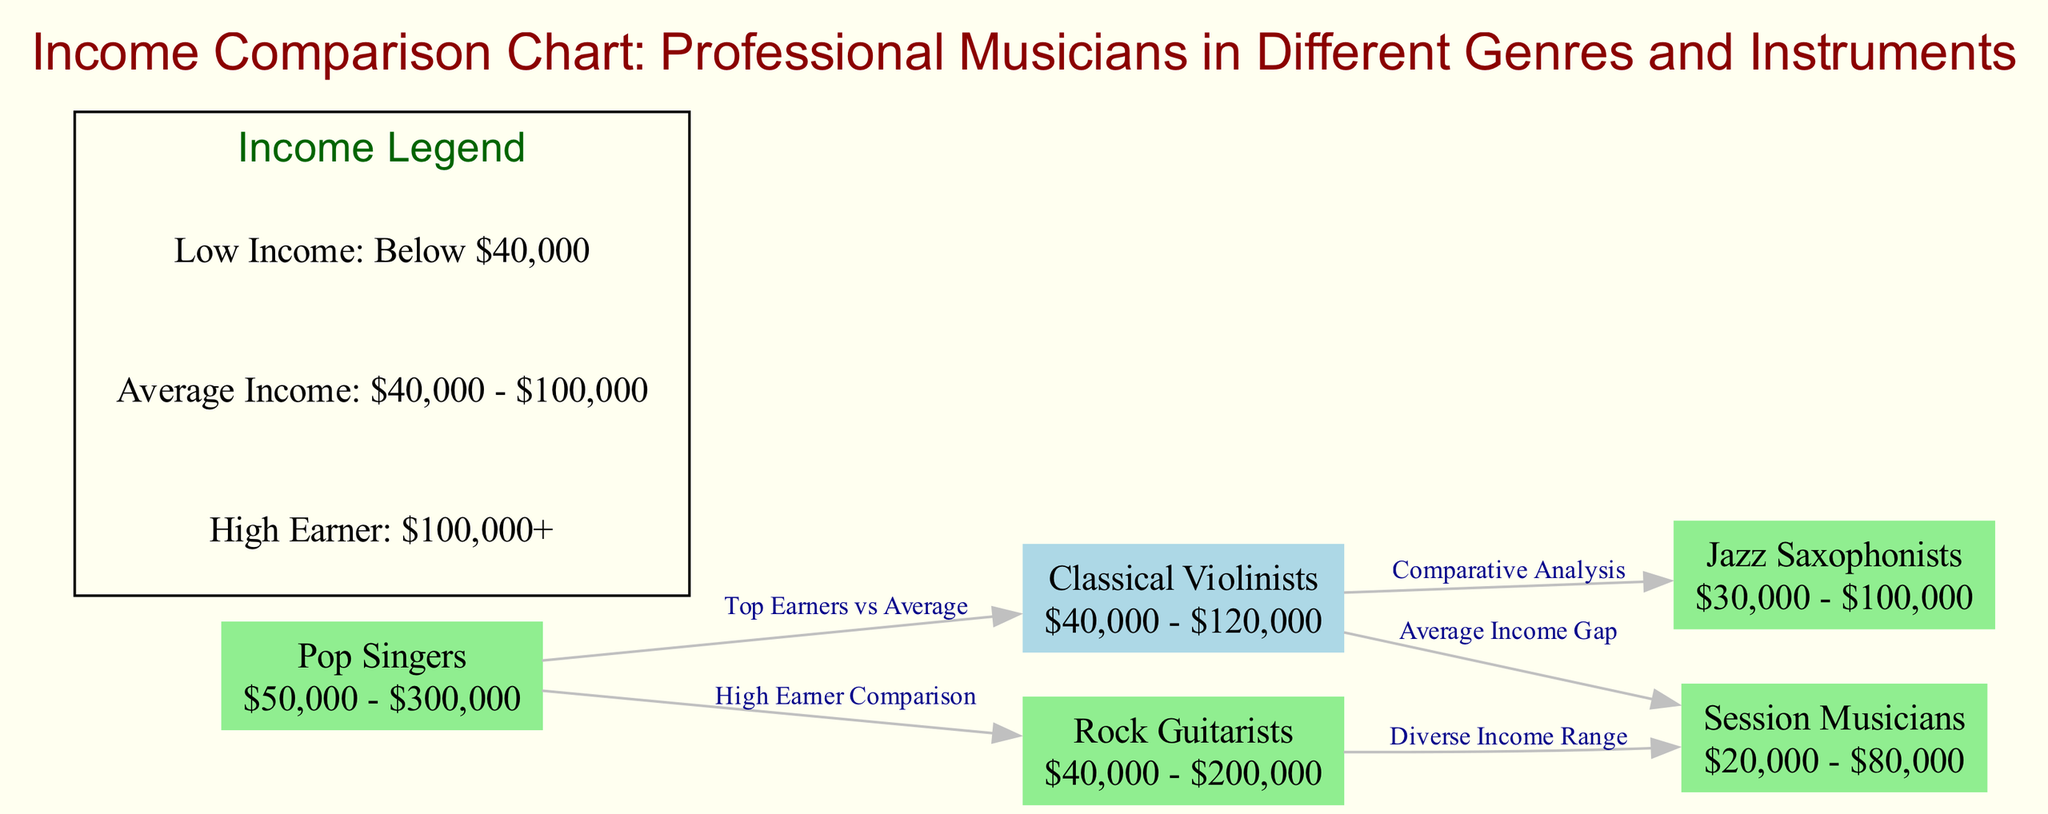What is the income range for Classical Violinists? The diagram shows that Classical Violinists have an income range of $40,000 - $120,000, which is included in the label of that node.
Answer: $40,000 - $120,000 How many nodes are represented in the diagram? By counting the nodes listed in the provided data, we find there are five distinct nodes: Classical Violinists, Jazz Saxophonists, Pop Singers, Rock Guitarists, and Session Musicians.
Answer: 5 Which genre has the highest potential income range? The Pop Singers node indicates an income range of $50,000 - $300,000, which is higher than the ranges for all other genres in the diagram.
Answer: Pop Singers What is the income gap between Classical Violinists and Session Musicians? To find the income gap, we examine the income ranges: Classical Violinists ($40,000 - $120,000) and Session Musicians ($20,000 - $80,000). This indicates a noticeable difference with Classical Violinists earning more on average.
Answer: Average Income Gap What label connects Pop Singers and Classical Violinists? The diagram details that the connection between Pop Singers and Classical Violinists is labeled "Top Earners vs Average," illustrating a comparative relationship between their income levels.
Answer: Top Earners vs Average What is the income range for Session Musicians? As stated in the node for Session Musicians, their income range is $20,000 - $80,000, which is directly mentioned in the diagram.
Answer: $20,000 - $80,000 Which two types of musicians have a comparative analysis relationship? By examining the edges in the diagram, we see that Classical Violinists and Jazz Saxophonists share a comparative analysis label, linking their information together explicitly.
Answer: Classical Violinists and Jazz Saxophonists What color represents Classical Violinists in the diagram? The diagram colors Classical Violinists' node in light blue, which differentiates it visually from the other genres represented in light green.
Answer: Light Blue What is indicated by the edge from Rock Guitarists to Session Musicians? The edge labeled "Diverse Income Range" signifies that while both Rock Guitarists and Session Musicians have their own ranges, Rock Guitarists exhibit a broader income range compared to Session Musicians.
Answer: Diverse Income Range 